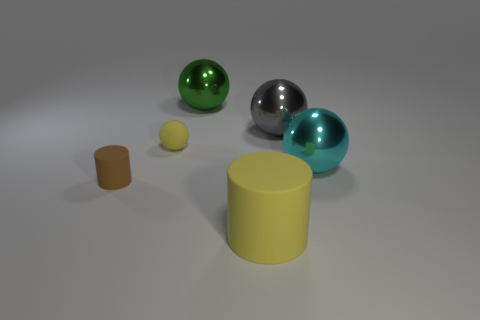Subtract all green metal spheres. How many spheres are left? 3 Subtract 2 cylinders. How many cylinders are left? 0 Subtract all spheres. How many objects are left? 2 Add 1 green shiny things. How many objects exist? 7 Subtract all large yellow blocks. Subtract all yellow rubber spheres. How many objects are left? 5 Add 6 large gray balls. How many large gray balls are left? 7 Add 5 big brown cubes. How many big brown cubes exist? 5 Subtract all brown cylinders. How many cylinders are left? 1 Subtract 0 yellow cubes. How many objects are left? 6 Subtract all red balls. Subtract all cyan blocks. How many balls are left? 4 